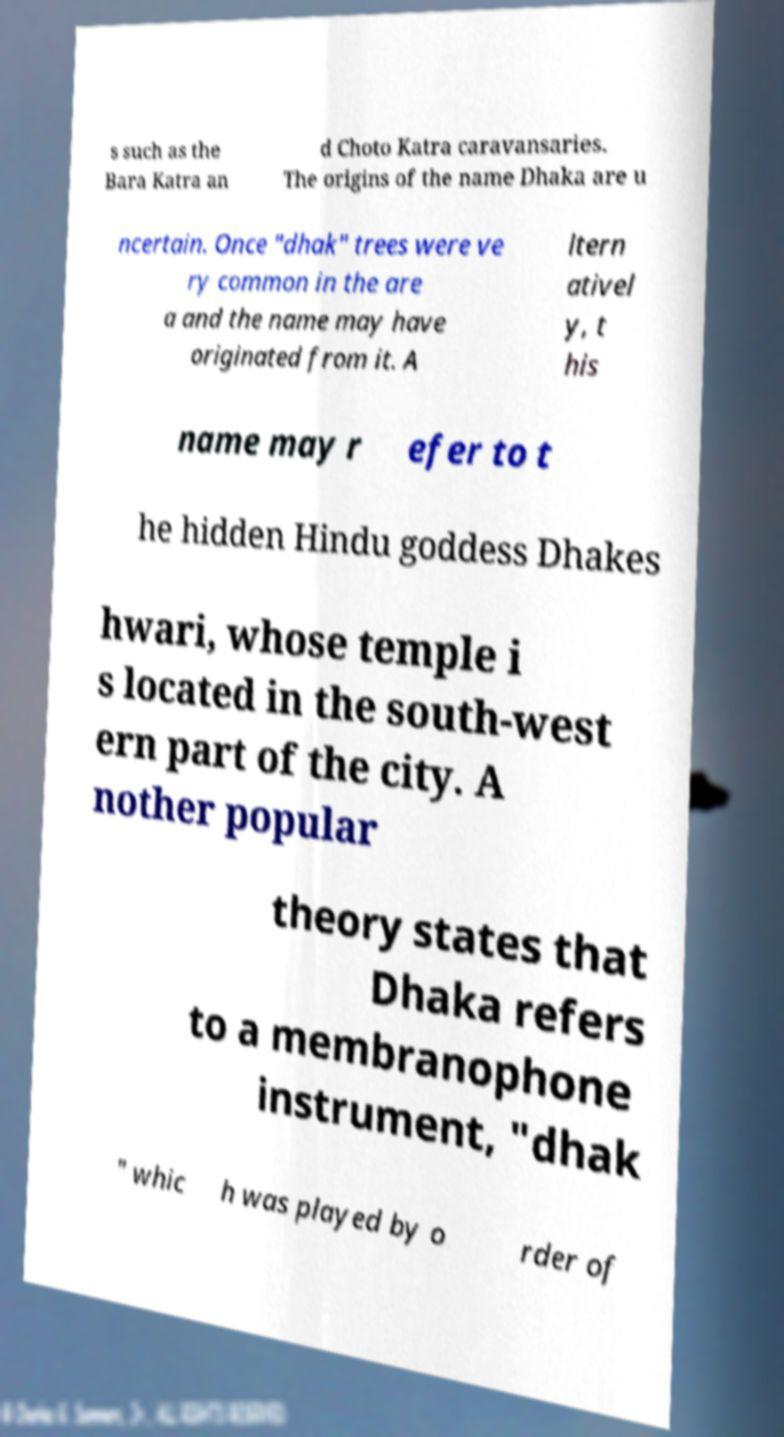Could you assist in decoding the text presented in this image and type it out clearly? s such as the Bara Katra an d Choto Katra caravansaries. The origins of the name Dhaka are u ncertain. Once "dhak" trees were ve ry common in the are a and the name may have originated from it. A ltern ativel y, t his name may r efer to t he hidden Hindu goddess Dhakes hwari, whose temple i s located in the south-west ern part of the city. A nother popular theory states that Dhaka refers to a membranophone instrument, "dhak " whic h was played by o rder of 